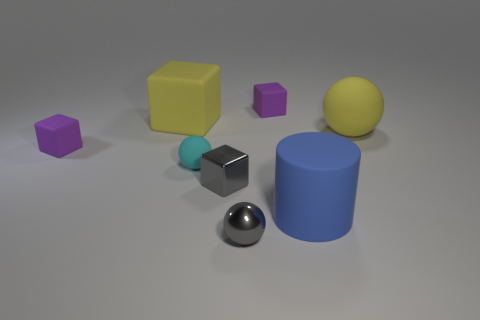Subtract all big yellow matte blocks. How many blocks are left? 3 Subtract all gray spheres. How many spheres are left? 2 Add 1 big gray rubber cylinders. How many objects exist? 9 Subtract all cylinders. How many objects are left? 7 Subtract 1 cubes. How many cubes are left? 3 Subtract all cyan cubes. Subtract all brown cylinders. How many cubes are left? 4 Subtract all gray cylinders. How many gray spheres are left? 1 Subtract all big green shiny blocks. Subtract all large yellow spheres. How many objects are left? 7 Add 5 large blocks. How many large blocks are left? 6 Add 8 big cyan blocks. How many big cyan blocks exist? 8 